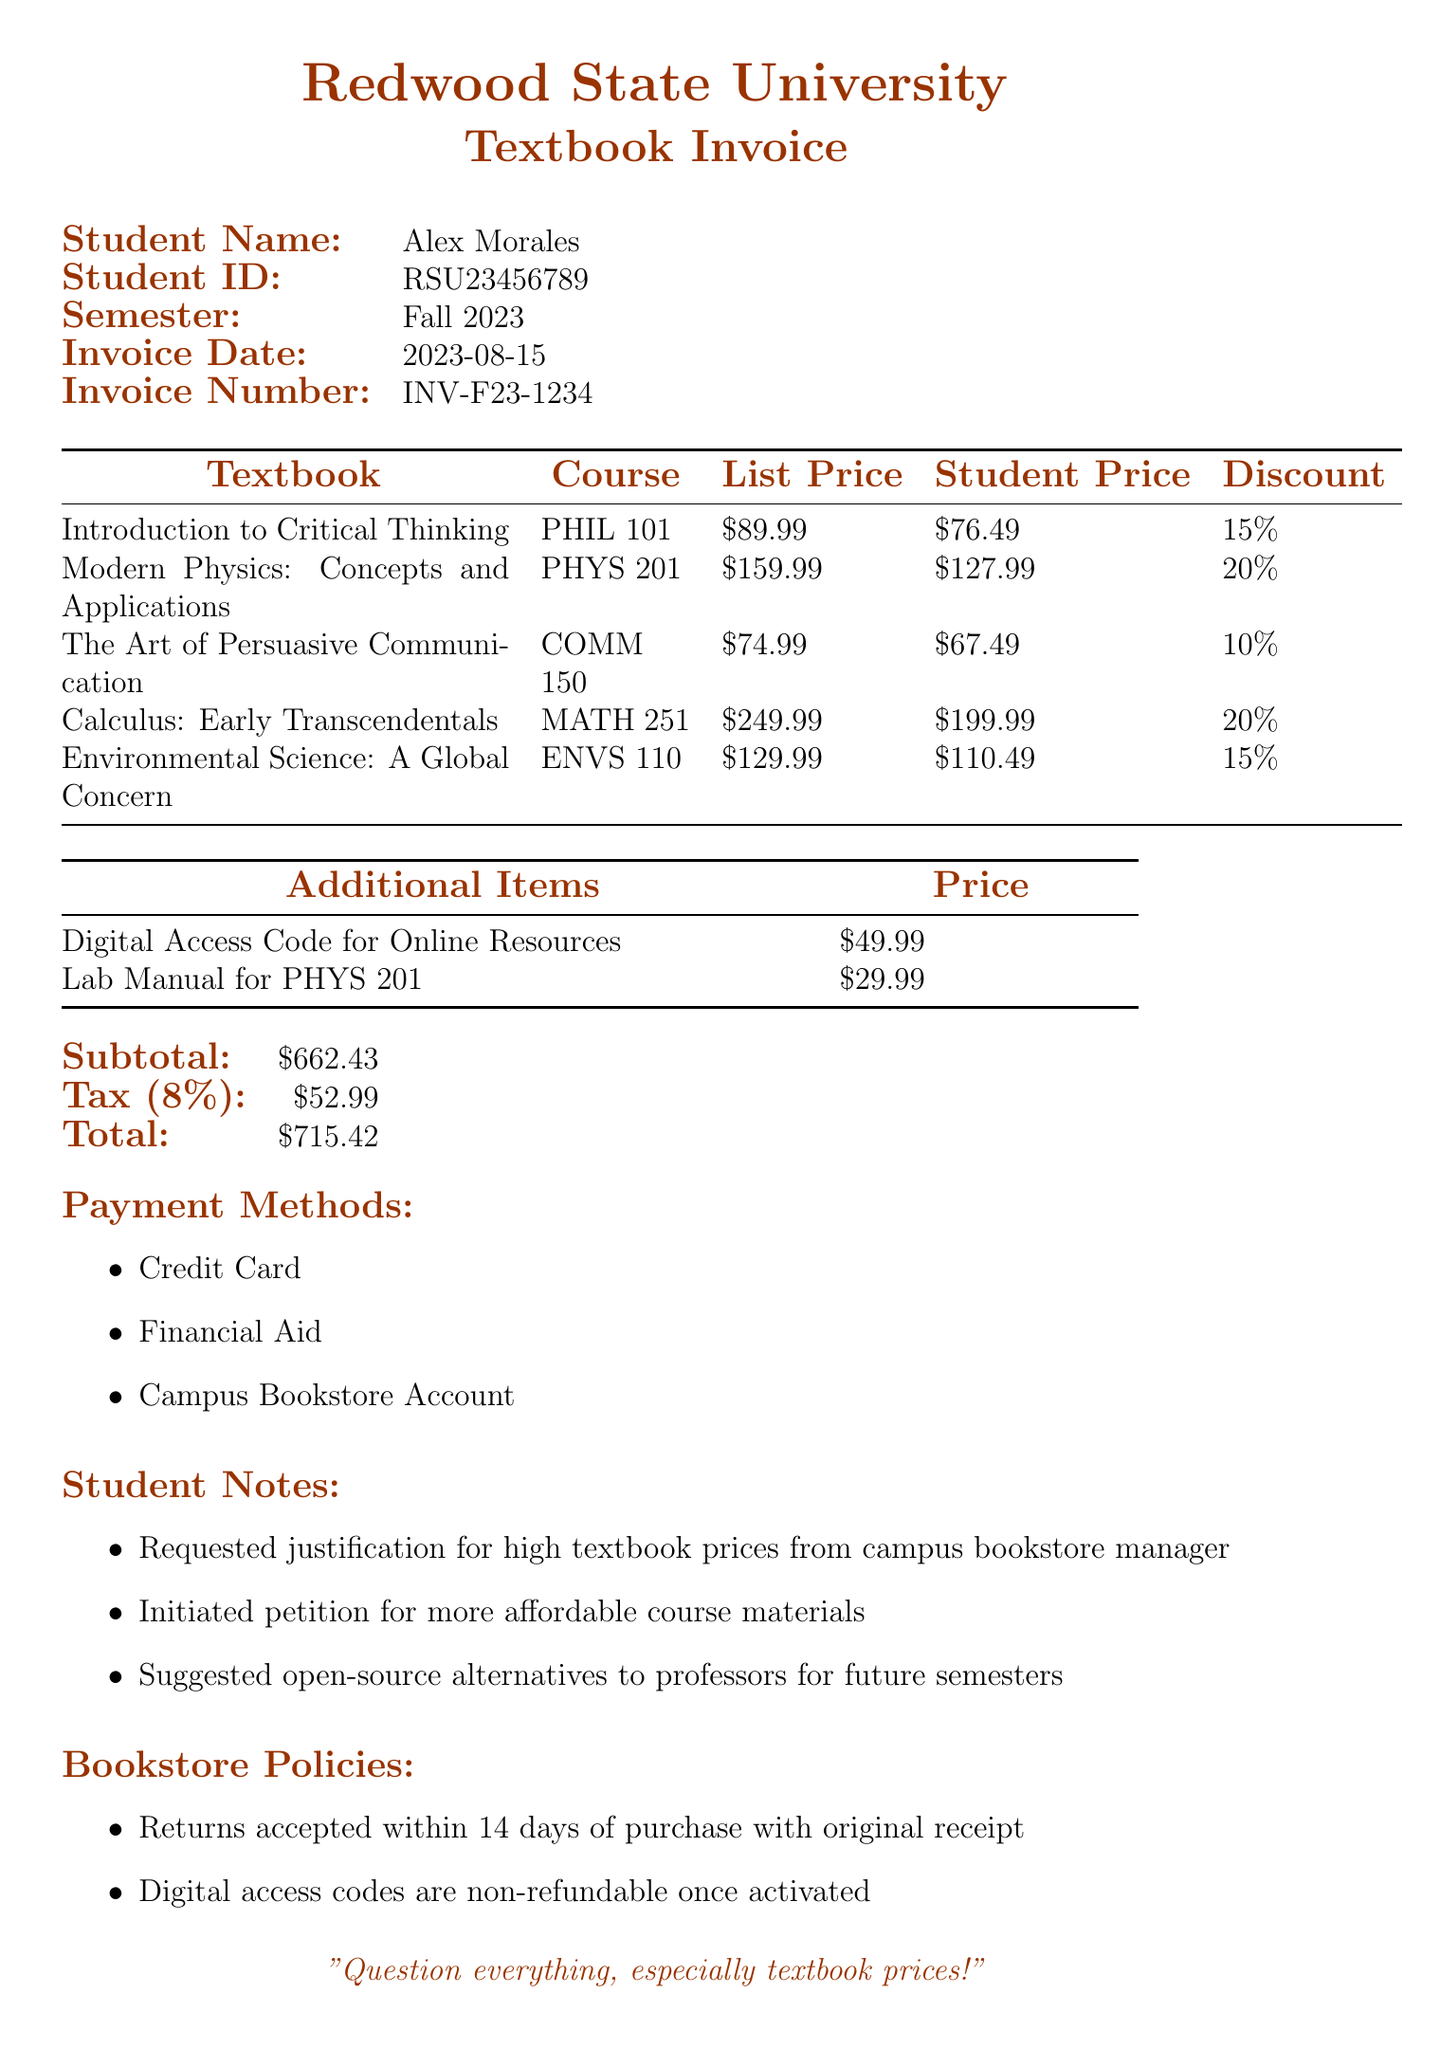what is the student name? The student's name is provided in the invoice details.
Answer: Alex Morales what is the semester for this invoice? The semester indicated in the document is specified under the student details.
Answer: Fall 2023 what is the invoice date? The date of the invoice is explicitly mentioned in the document.
Answer: 2023-08-15 what was the discount applied to "Calculus: Early Transcendentals"? The discount for this textbook is noted in the pricing section of the document.
Answer: 20% what is the subtotal amount? The subtotal is calculated before tax and is separately listed in the document.
Answer: $662.43 how many additional items are listed? The number of additional items is counted from the additional items section of the invoice.
Answer: 2 what is the total amount due? The total amount to be paid is clearly stated at the end of the invoice.
Answer: $715.42 what payment methods are available? The different payment methods are outlined in a dedicated section.
Answer: Credit Card, Financial Aid, Campus Bookstore Account how long do students have to return items? The return policy duration is specified in the bookstore policies.
Answer: 14 days 